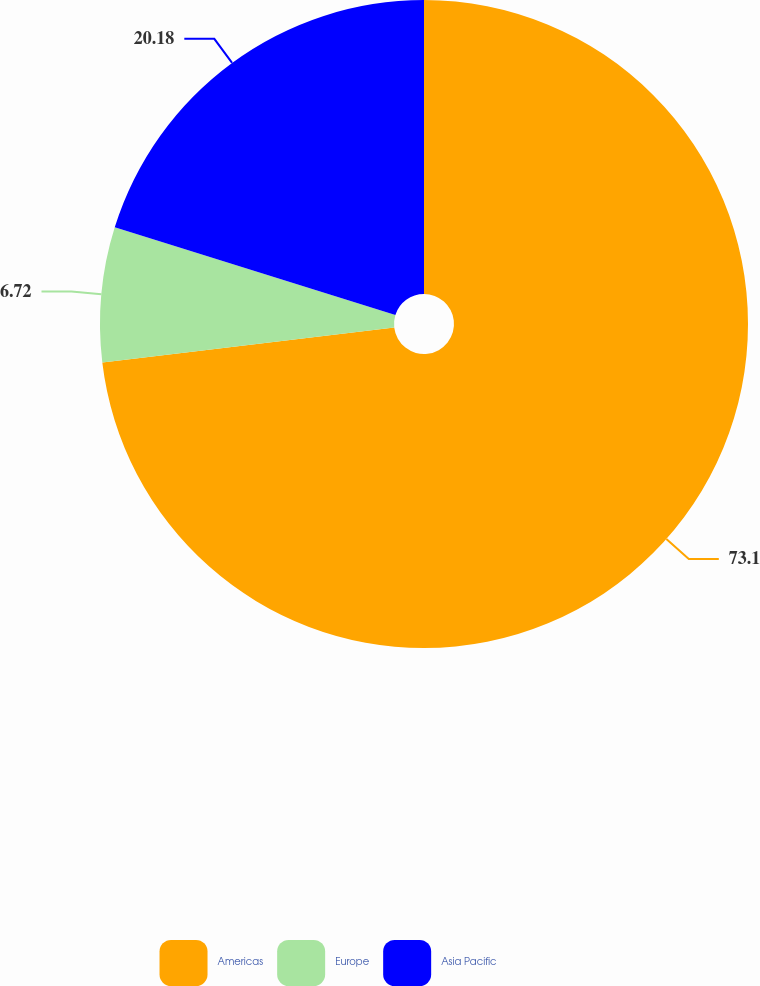<chart> <loc_0><loc_0><loc_500><loc_500><pie_chart><fcel>Americas<fcel>Europe<fcel>Asia Pacific<nl><fcel>73.1%<fcel>6.72%<fcel>20.18%<nl></chart> 